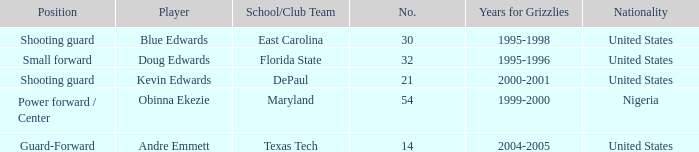When did no. 32 play for grizzles 1995-1996. 